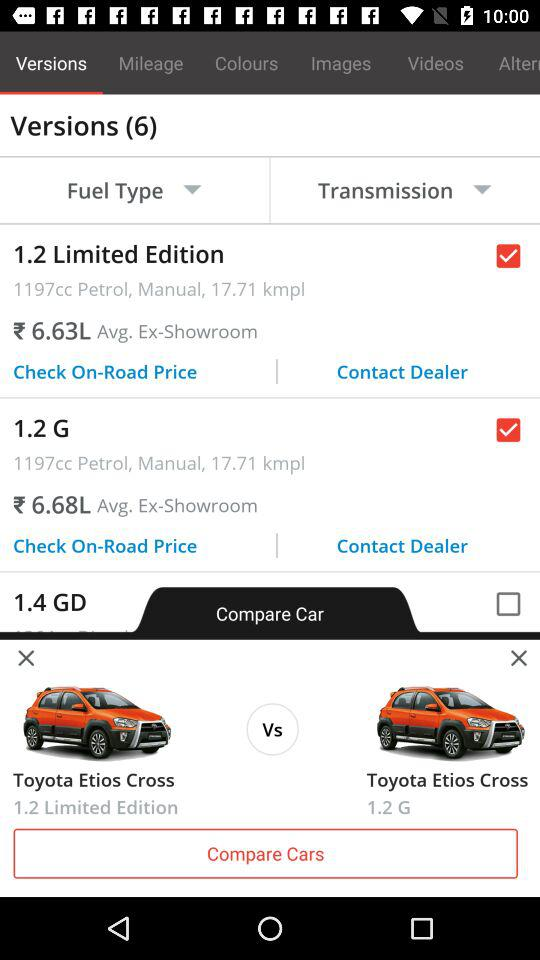How many versions have a manual transmission?
Answer the question using a single word or phrase. 2 